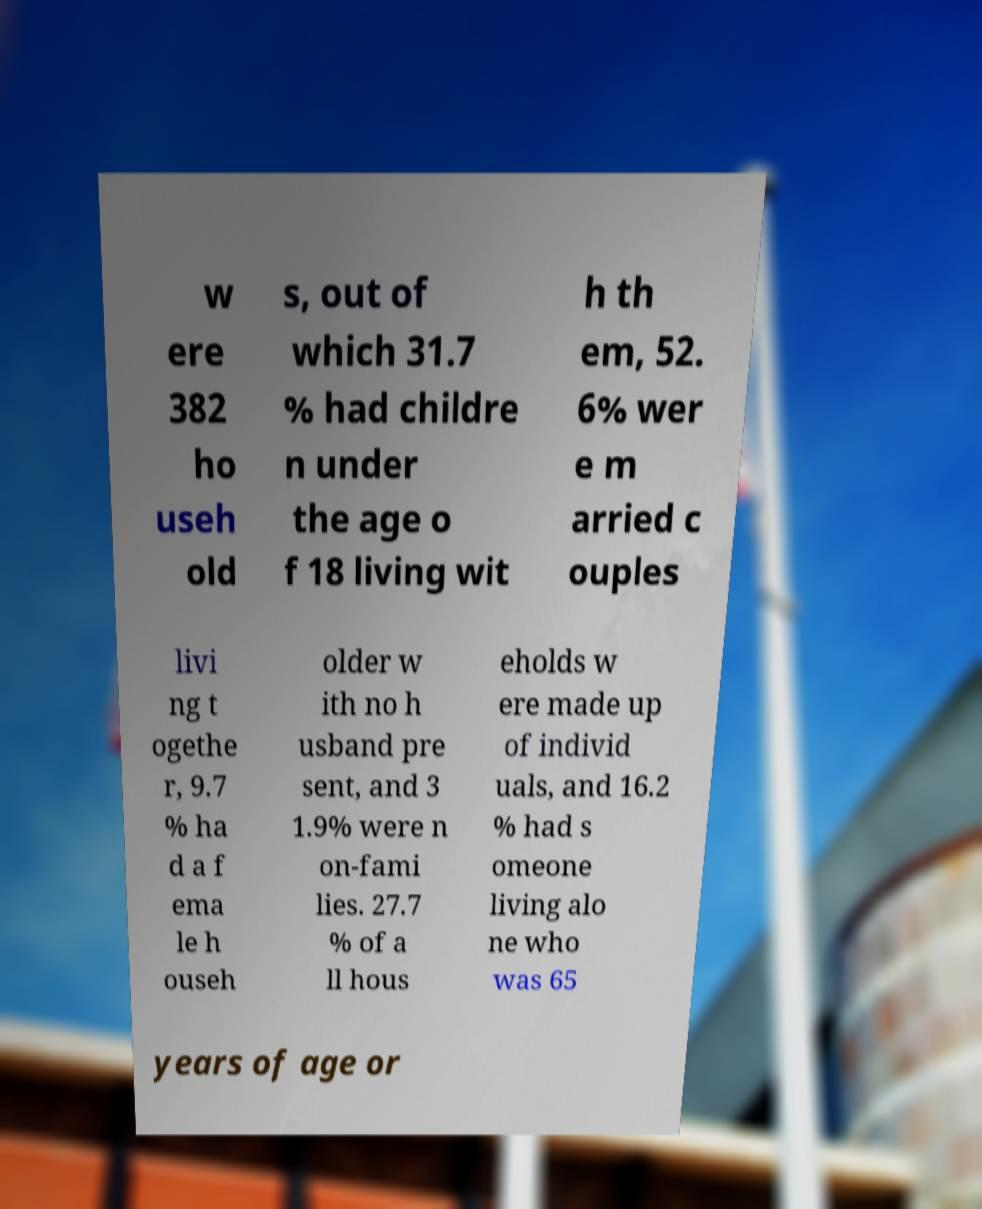Can you read and provide the text displayed in the image?This photo seems to have some interesting text. Can you extract and type it out for me? w ere 382 ho useh old s, out of which 31.7 % had childre n under the age o f 18 living wit h th em, 52. 6% wer e m arried c ouples livi ng t ogethe r, 9.7 % ha d a f ema le h ouseh older w ith no h usband pre sent, and 3 1.9% were n on-fami lies. 27.7 % of a ll hous eholds w ere made up of individ uals, and 16.2 % had s omeone living alo ne who was 65 years of age or 